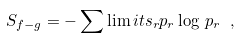Convert formula to latex. <formula><loc_0><loc_0><loc_500><loc_500>S _ { f - g } = - \sum \lim i t s _ { r } p _ { r } \log \, p _ { r } \ ,</formula> 